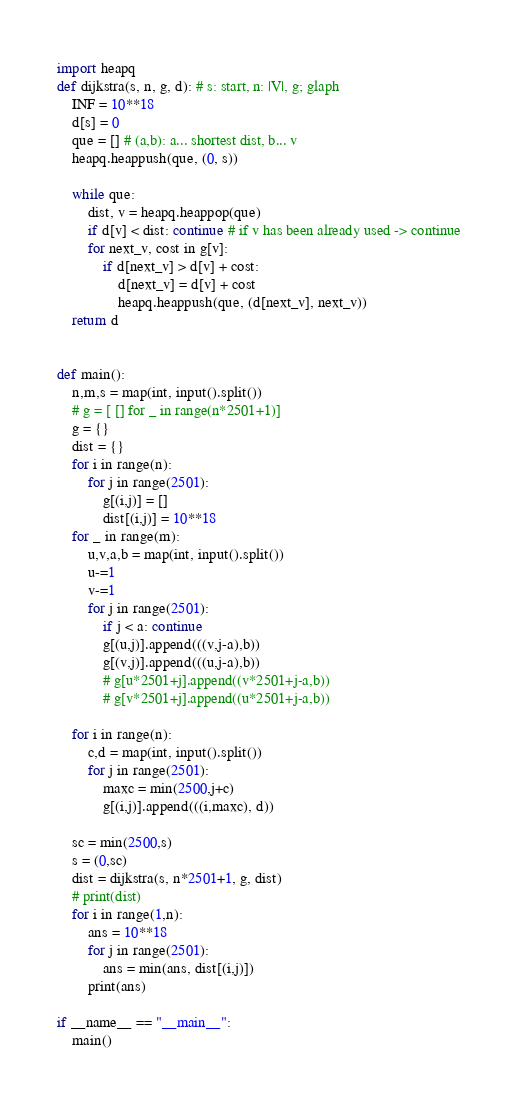Convert code to text. <code><loc_0><loc_0><loc_500><loc_500><_Python_>import heapq
def dijkstra(s, n, g, d): # s: start, n: |V|, g; glaph 
    INF = 10**18
    d[s] = 0
    que = [] # (a,b): a... shortest dist, b... v
    heapq.heappush(que, (0, s))

    while que:
        dist, v = heapq.heappop(que)
        if d[v] < dist: continue # if v has been already used -> continue
        for next_v, cost in g[v]:
            if d[next_v] > d[v] + cost:
                d[next_v] = d[v] + cost
                heapq.heappush(que, (d[next_v], next_v))
    return d


def main():
    n,m,s = map(int, input().split())
    # g = [ [] for _ in range(n*2501+1)]
    g = {}
    dist = {}
    for i in range(n):
        for j in range(2501):
            g[(i,j)] = []
            dist[(i,j)] = 10**18
    for _ in range(m):
        u,v,a,b = map(int, input().split())
        u-=1
        v-=1
        for j in range(2501):
            if j < a: continue
            g[(u,j)].append(((v,j-a),b))
            g[(v,j)].append(((u,j-a),b))
            # g[u*2501+j].append((v*2501+j-a,b))
            # g[v*2501+j].append((u*2501+j-a,b))

    for i in range(n):
        c,d = map(int, input().split())
        for j in range(2501):
            maxc = min(2500,j+c)
            g[(i,j)].append(((i,maxc), d))

    sc = min(2500,s)
    s = (0,sc)
    dist = dijkstra(s, n*2501+1, g, dist)
    # print(dist)
    for i in range(1,n):
        ans = 10**18
        for j in range(2501):
            ans = min(ans, dist[(i,j)])
        print(ans)

if __name__ == "__main__":
    main()</code> 